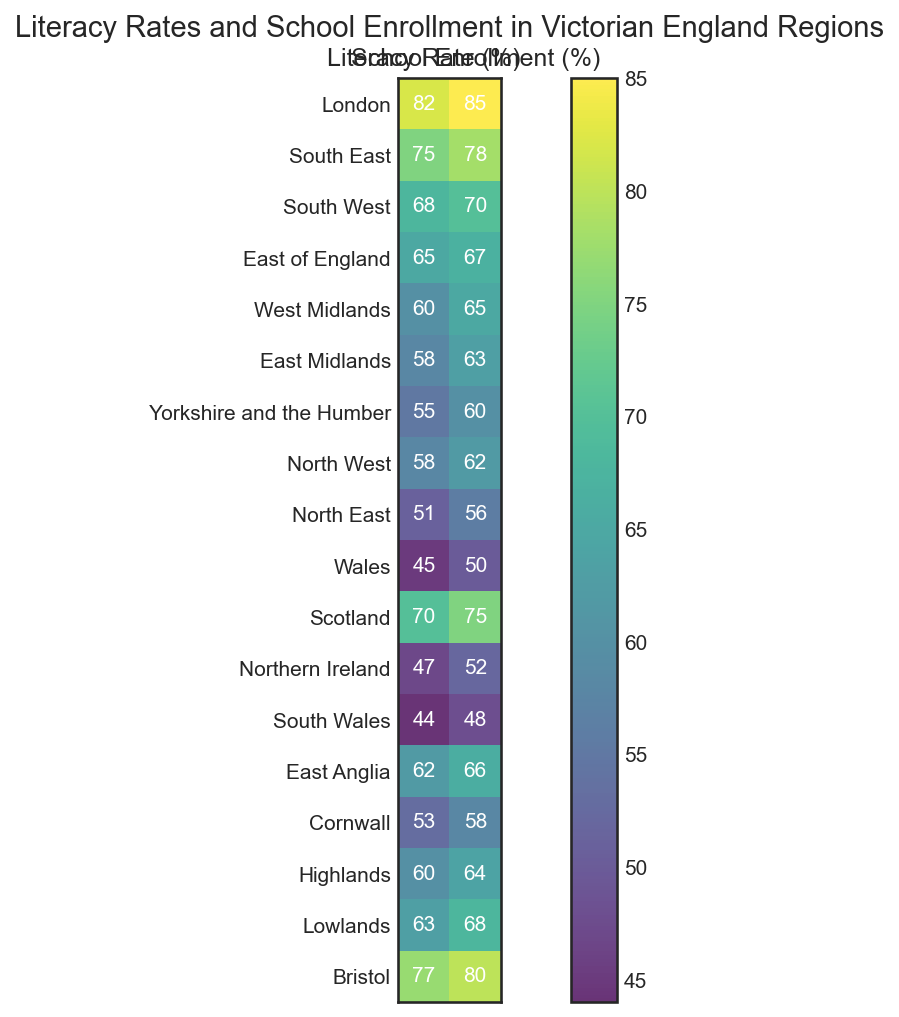Which region has the highest literacy rate? From the heatmap, look for the region with the darkest coloration within the 'Literacy Rate (%)' column. London has the highest value, 82%.
Answer: London Which region shows equal literacy and school enrollment rates? Find the region where both values in the heatmap match in the 'Literacy Rate (%)' and 'School Enrollment (%)' columns. There is no region with equal values for both literacy and school enrollment.
Answer: None What is the total literacy rate of all southern regions (South East, South West, South Wales, East Anglia, and Cornwall)? Sum the literacy rates for these regions: 75 (South East) + 68 (South West) + 44 (South Wales) + 62 (East Anglia) + 53 (Cornwall) = 302
Answer: 302 Which region has the largest gap between literacy rate and school enrollment percentage? Calculate the difference between literacy rate and school enrollment for each region and identify the highest difference. South Wales has the largest gap: 48 - 44 = 4.
Answer: South Wales Compare the school enrollment percentages of Bristol and Wales. Which one is higher? Look at the school enrollment rates in the heatmap for both Bristol and Wales. Bristol has 80% while Wales has 50%. Therefore, Bristol's rate is higher.
Answer: Bristol Which region has the lowest school enrollment percentage? Locate the region with the lightest coloration within the 'School Enrollment (%)' column. South Wales has the lowest school enrollment percentage at 48%.
Answer: South Wales What is the average literacy rate across all regions? Sum all the literacy rates and divide by the number of regions: (82 + 75 + 68 + 65 + 60 + 58 + 55 + 58 + 51 + 45 + 70 + 47 + 44 + 62 + 53 + 60 + 63 + 77) / 18 ≈ 61.1
Answer: 61.1 Find the region with a school enrollment rate that is closest to 60%? Scan the 'School Enrollment (%)' column to locate the rate closest to 60%. Yorkshire and the Humber has 60%, exactly.
Answer: Yorkshire and the Humber Which is higher: the literacy rate of the West Midlands or the school enrollment of the East Midlands? Refer to the values for West Midlands literacy rate and East Midlands school enrollment. West Midlands has 60% literacy, and East Midlands has 63% enrollment. 63% is higher.
Answer: East Midlands Compare the literacy rates for Scotland and Northern Ireland, which region has a higher rate? Find the literacy rates for both regions in the heatmap. Scotland has 70% and Northern Ireland has 47%. Scotland has a higher rate.
Answer: Scotland 